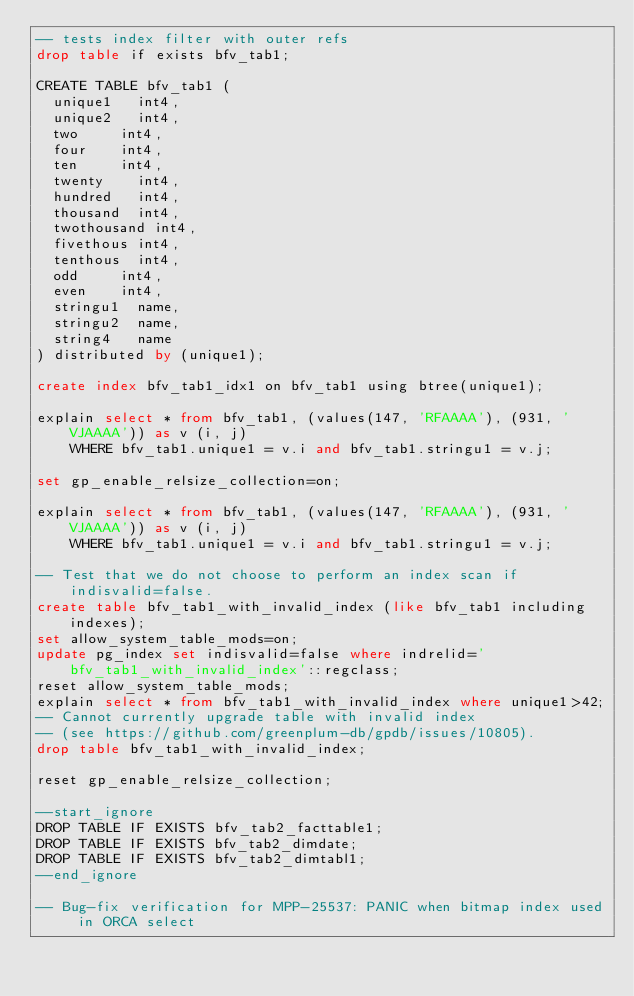Convert code to text. <code><loc_0><loc_0><loc_500><loc_500><_SQL_>-- tests index filter with outer refs
drop table if exists bfv_tab1;

CREATE TABLE bfv_tab1 (
	unique1		int4,
	unique2		int4,
	two			int4,
	four		int4,
	ten			int4,
	twenty		int4,
	hundred		int4,
	thousand	int4,
	twothousand	int4,
	fivethous	int4,
	tenthous	int4,
	odd			int4,
	even		int4,
	stringu1	name,
	stringu2	name,
	string4		name
) distributed by (unique1);

create index bfv_tab1_idx1 on bfv_tab1 using btree(unique1);

explain select * from bfv_tab1, (values(147, 'RFAAAA'), (931, 'VJAAAA')) as v (i, j)
    WHERE bfv_tab1.unique1 = v.i and bfv_tab1.stringu1 = v.j;

set gp_enable_relsize_collection=on;

explain select * from bfv_tab1, (values(147, 'RFAAAA'), (931, 'VJAAAA')) as v (i, j)
    WHERE bfv_tab1.unique1 = v.i and bfv_tab1.stringu1 = v.j;

-- Test that we do not choose to perform an index scan if indisvalid=false.
create table bfv_tab1_with_invalid_index (like bfv_tab1 including indexes);
set allow_system_table_mods=on;
update pg_index set indisvalid=false where indrelid='bfv_tab1_with_invalid_index'::regclass;
reset allow_system_table_mods;
explain select * from bfv_tab1_with_invalid_index where unique1>42;
-- Cannot currently upgrade table with invalid index
-- (see https://github.com/greenplum-db/gpdb/issues/10805).
drop table bfv_tab1_with_invalid_index;

reset gp_enable_relsize_collection;

--start_ignore
DROP TABLE IF EXISTS bfv_tab2_facttable1;
DROP TABLE IF EXISTS bfv_tab2_dimdate;
DROP TABLE IF EXISTS bfv_tab2_dimtabl1;
--end_ignore

-- Bug-fix verification for MPP-25537: PANIC when bitmap index used in ORCA select</code> 